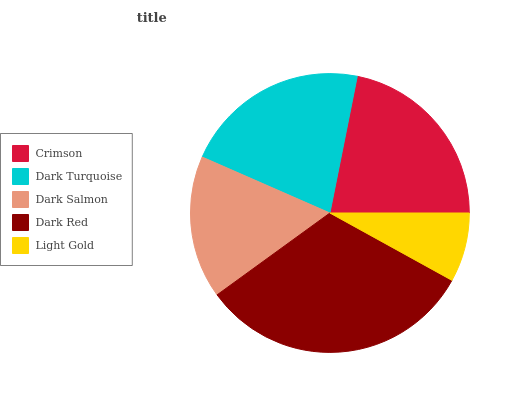Is Light Gold the minimum?
Answer yes or no. Yes. Is Dark Red the maximum?
Answer yes or no. Yes. Is Dark Turquoise the minimum?
Answer yes or no. No. Is Dark Turquoise the maximum?
Answer yes or no. No. Is Crimson greater than Dark Turquoise?
Answer yes or no. Yes. Is Dark Turquoise less than Crimson?
Answer yes or no. Yes. Is Dark Turquoise greater than Crimson?
Answer yes or no. No. Is Crimson less than Dark Turquoise?
Answer yes or no. No. Is Dark Turquoise the high median?
Answer yes or no. Yes. Is Dark Turquoise the low median?
Answer yes or no. Yes. Is Crimson the high median?
Answer yes or no. No. Is Dark Red the low median?
Answer yes or no. No. 